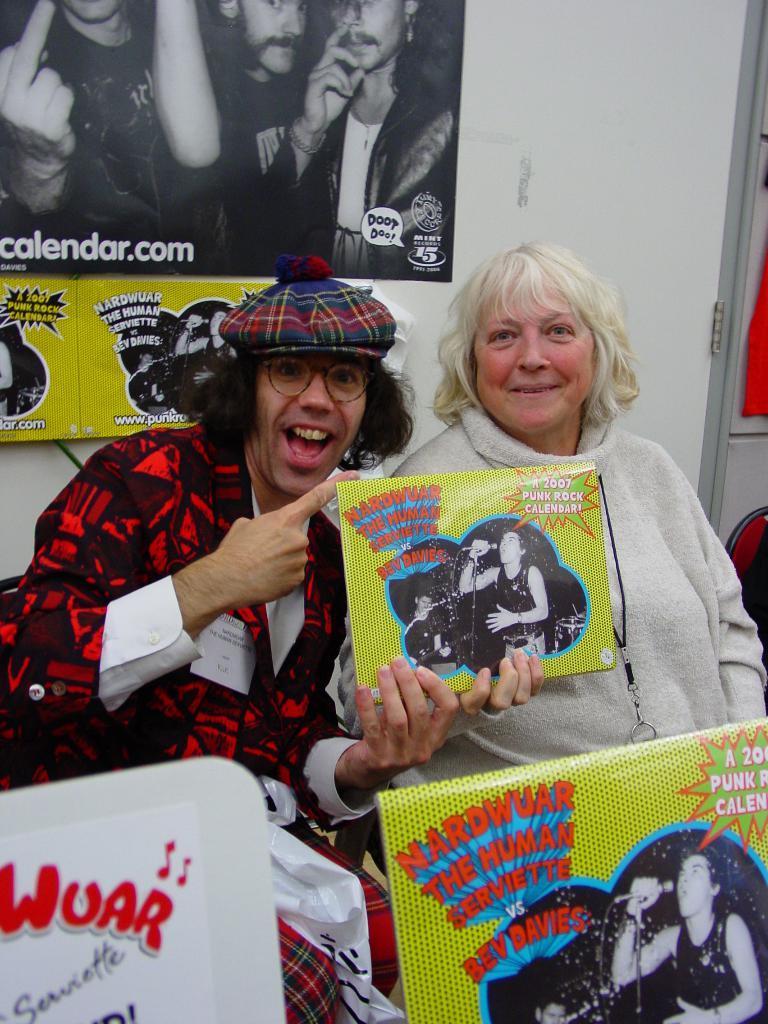Describe this image in one or two sentences. In this image we can see two persons and among them a person is holding a poster. Behind the person we can see a wall. On the wall we can see the posters and on the posters we can see the text and images of the persons. On the right side, we can see a door and a chair. At the bottom we can see the posters. 